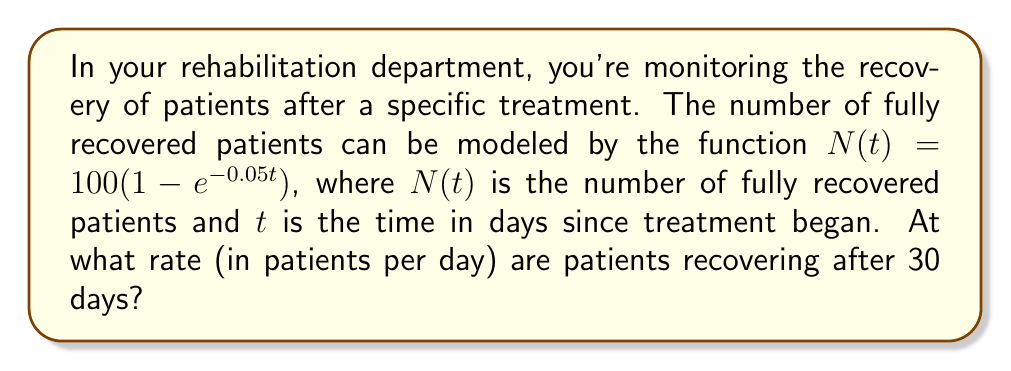Teach me how to tackle this problem. To find the rate of patient recovery at 30 days, we need to calculate the derivative of the given function and evaluate it at $t = 30$. Here's the step-by-step process:

1) The given function is $N(t) = 100(1 - e^{-0.05t})$

2) To find the rate of change, we need to differentiate $N(t)$ with respect to $t$:

   $$\frac{dN}{dt} = 100 \cdot \frac{d}{dt}(1 - e^{-0.05t})$$
   $$= 100 \cdot (-1) \cdot (-0.05e^{-0.05t})$$
   $$= 5e^{-0.05t}$$

3) This derivative $\frac{dN}{dt}$ represents the instantaneous rate of patient recovery at any time $t$.

4) To find the rate after 30 days, we substitute $t = 30$ into this expression:

   $$\frac{dN}{dt}|_{t=30} = 5e^{-0.05(30)}$$
   $$= 5e^{-1.5}$$
   $$\approx 1.1157$$

5) Therefore, after 30 days, patients are recovering at a rate of approximately 1.1157 patients per day.
Answer: $5e^{-1.5}$ patients/day 